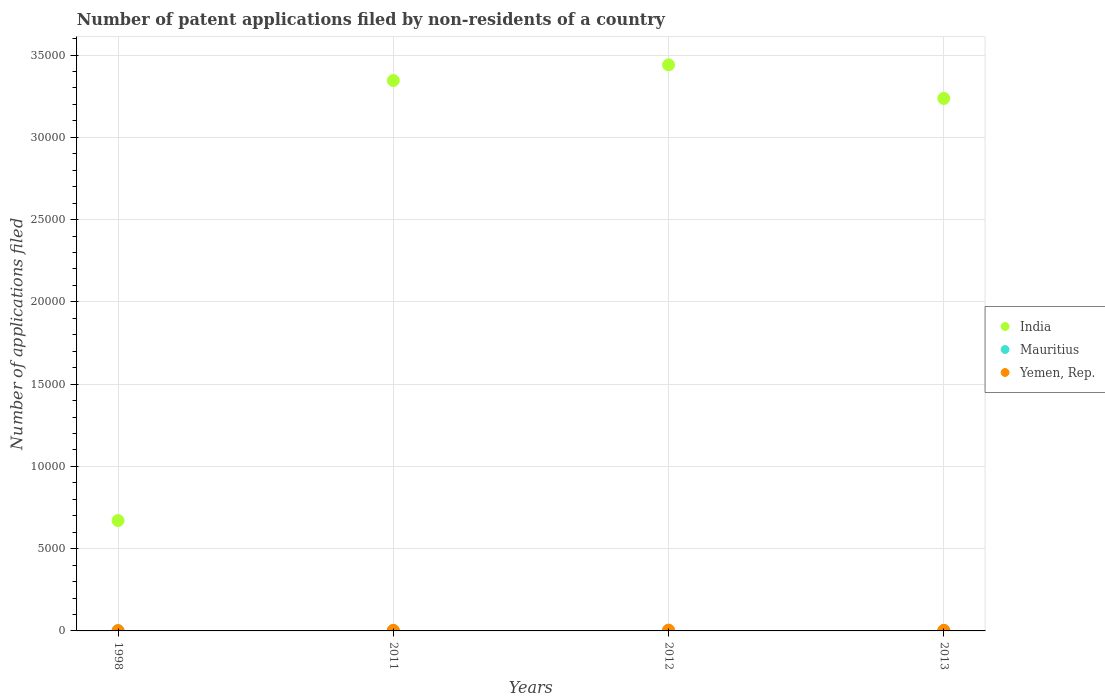How many different coloured dotlines are there?
Keep it short and to the point. 3. Is the number of dotlines equal to the number of legend labels?
Offer a terse response. Yes. Across all years, what is the maximum number of applications filed in India?
Your answer should be very brief. 3.44e+04. Across all years, what is the minimum number of applications filed in Mauritius?
Ensure brevity in your answer.  12. In which year was the number of applications filed in India maximum?
Offer a very short reply. 2012. In which year was the number of applications filed in India minimum?
Your answer should be compact. 1998. What is the total number of applications filed in India in the graph?
Ensure brevity in your answer.  1.07e+05. What is the difference between the number of applications filed in India in 2011 and that in 2012?
Your answer should be compact. -952. What is the difference between the number of applications filed in India in 2013 and the number of applications filed in Mauritius in 2012?
Your answer should be very brief. 3.23e+04. What is the average number of applications filed in Mauritius per year?
Keep it short and to the point. 15.75. In the year 2012, what is the difference between the number of applications filed in Mauritius and number of applications filed in Yemen, Rep.?
Provide a succinct answer. -35. In how many years, is the number of applications filed in Yemen, Rep. greater than 1000?
Your answer should be compact. 0. What is the ratio of the number of applications filed in India in 2011 to that in 2013?
Offer a terse response. 1.03. Is the difference between the number of applications filed in Mauritius in 2011 and 2012 greater than the difference between the number of applications filed in Yemen, Rep. in 2011 and 2012?
Your response must be concise. Yes. What is the difference between the highest and the second highest number of applications filed in Mauritius?
Give a very brief answer. 1. What is the difference between the highest and the lowest number of applications filed in India?
Keep it short and to the point. 2.77e+04. In how many years, is the number of applications filed in India greater than the average number of applications filed in India taken over all years?
Ensure brevity in your answer.  3. Is the sum of the number of applications filed in India in 1998 and 2012 greater than the maximum number of applications filed in Yemen, Rep. across all years?
Give a very brief answer. Yes. Is the number of applications filed in Mauritius strictly greater than the number of applications filed in India over the years?
Your response must be concise. No. How many legend labels are there?
Offer a terse response. 3. How are the legend labels stacked?
Ensure brevity in your answer.  Vertical. What is the title of the graph?
Your answer should be very brief. Number of patent applications filed by non-residents of a country. Does "Solomon Islands" appear as one of the legend labels in the graph?
Give a very brief answer. No. What is the label or title of the X-axis?
Offer a very short reply. Years. What is the label or title of the Y-axis?
Your answer should be compact. Number of applications filed. What is the Number of applications filed of India in 1998?
Your response must be concise. 6707. What is the Number of applications filed of Yemen, Rep. in 1998?
Keep it short and to the point. 16. What is the Number of applications filed in India in 2011?
Your response must be concise. 3.34e+04. What is the Number of applications filed in Mauritius in 2011?
Offer a very short reply. 19. What is the Number of applications filed in India in 2012?
Provide a short and direct response. 3.44e+04. What is the Number of applications filed in India in 2013?
Offer a very short reply. 3.24e+04. What is the Number of applications filed in Mauritius in 2013?
Keep it short and to the point. 18. Across all years, what is the maximum Number of applications filed in India?
Your response must be concise. 3.44e+04. Across all years, what is the maximum Number of applications filed of Yemen, Rep.?
Your answer should be very brief. 49. Across all years, what is the minimum Number of applications filed in India?
Give a very brief answer. 6707. Across all years, what is the minimum Number of applications filed in Mauritius?
Ensure brevity in your answer.  12. Across all years, what is the minimum Number of applications filed in Yemen, Rep.?
Offer a terse response. 16. What is the total Number of applications filed of India in the graph?
Make the answer very short. 1.07e+05. What is the total Number of applications filed in Yemen, Rep. in the graph?
Make the answer very short. 139. What is the difference between the Number of applications filed in India in 1998 and that in 2011?
Offer a terse response. -2.67e+04. What is the difference between the Number of applications filed of Yemen, Rep. in 1998 and that in 2011?
Your answer should be very brief. -21. What is the difference between the Number of applications filed of India in 1998 and that in 2012?
Ensure brevity in your answer.  -2.77e+04. What is the difference between the Number of applications filed in Yemen, Rep. in 1998 and that in 2012?
Offer a terse response. -33. What is the difference between the Number of applications filed of India in 1998 and that in 2013?
Ensure brevity in your answer.  -2.57e+04. What is the difference between the Number of applications filed of Mauritius in 1998 and that in 2013?
Make the answer very short. -6. What is the difference between the Number of applications filed in India in 2011 and that in 2012?
Ensure brevity in your answer.  -952. What is the difference between the Number of applications filed in Mauritius in 2011 and that in 2012?
Give a very brief answer. 5. What is the difference between the Number of applications filed of Yemen, Rep. in 2011 and that in 2012?
Your response must be concise. -12. What is the difference between the Number of applications filed of India in 2011 and that in 2013?
Provide a short and direct response. 1088. What is the difference between the Number of applications filed of Mauritius in 2011 and that in 2013?
Keep it short and to the point. 1. What is the difference between the Number of applications filed in Yemen, Rep. in 2011 and that in 2013?
Your answer should be very brief. 0. What is the difference between the Number of applications filed of India in 2012 and that in 2013?
Keep it short and to the point. 2040. What is the difference between the Number of applications filed in Yemen, Rep. in 2012 and that in 2013?
Provide a succinct answer. 12. What is the difference between the Number of applications filed in India in 1998 and the Number of applications filed in Mauritius in 2011?
Offer a terse response. 6688. What is the difference between the Number of applications filed in India in 1998 and the Number of applications filed in Yemen, Rep. in 2011?
Offer a terse response. 6670. What is the difference between the Number of applications filed of India in 1998 and the Number of applications filed of Mauritius in 2012?
Your answer should be compact. 6693. What is the difference between the Number of applications filed of India in 1998 and the Number of applications filed of Yemen, Rep. in 2012?
Provide a short and direct response. 6658. What is the difference between the Number of applications filed in Mauritius in 1998 and the Number of applications filed in Yemen, Rep. in 2012?
Provide a succinct answer. -37. What is the difference between the Number of applications filed of India in 1998 and the Number of applications filed of Mauritius in 2013?
Your answer should be very brief. 6689. What is the difference between the Number of applications filed of India in 1998 and the Number of applications filed of Yemen, Rep. in 2013?
Provide a succinct answer. 6670. What is the difference between the Number of applications filed of India in 2011 and the Number of applications filed of Mauritius in 2012?
Provide a short and direct response. 3.34e+04. What is the difference between the Number of applications filed in India in 2011 and the Number of applications filed in Yemen, Rep. in 2012?
Your answer should be compact. 3.34e+04. What is the difference between the Number of applications filed in India in 2011 and the Number of applications filed in Mauritius in 2013?
Ensure brevity in your answer.  3.34e+04. What is the difference between the Number of applications filed in India in 2011 and the Number of applications filed in Yemen, Rep. in 2013?
Keep it short and to the point. 3.34e+04. What is the difference between the Number of applications filed of India in 2012 and the Number of applications filed of Mauritius in 2013?
Keep it short and to the point. 3.44e+04. What is the difference between the Number of applications filed in India in 2012 and the Number of applications filed in Yemen, Rep. in 2013?
Give a very brief answer. 3.44e+04. What is the difference between the Number of applications filed of Mauritius in 2012 and the Number of applications filed of Yemen, Rep. in 2013?
Provide a short and direct response. -23. What is the average Number of applications filed of India per year?
Make the answer very short. 2.67e+04. What is the average Number of applications filed of Mauritius per year?
Ensure brevity in your answer.  15.75. What is the average Number of applications filed of Yemen, Rep. per year?
Keep it short and to the point. 34.75. In the year 1998, what is the difference between the Number of applications filed in India and Number of applications filed in Mauritius?
Ensure brevity in your answer.  6695. In the year 1998, what is the difference between the Number of applications filed of India and Number of applications filed of Yemen, Rep.?
Keep it short and to the point. 6691. In the year 2011, what is the difference between the Number of applications filed of India and Number of applications filed of Mauritius?
Your response must be concise. 3.34e+04. In the year 2011, what is the difference between the Number of applications filed in India and Number of applications filed in Yemen, Rep.?
Provide a succinct answer. 3.34e+04. In the year 2011, what is the difference between the Number of applications filed in Mauritius and Number of applications filed in Yemen, Rep.?
Offer a terse response. -18. In the year 2012, what is the difference between the Number of applications filed of India and Number of applications filed of Mauritius?
Keep it short and to the point. 3.44e+04. In the year 2012, what is the difference between the Number of applications filed of India and Number of applications filed of Yemen, Rep.?
Your response must be concise. 3.44e+04. In the year 2012, what is the difference between the Number of applications filed of Mauritius and Number of applications filed of Yemen, Rep.?
Ensure brevity in your answer.  -35. In the year 2013, what is the difference between the Number of applications filed in India and Number of applications filed in Mauritius?
Your response must be concise. 3.23e+04. In the year 2013, what is the difference between the Number of applications filed in India and Number of applications filed in Yemen, Rep.?
Offer a very short reply. 3.23e+04. What is the ratio of the Number of applications filed in India in 1998 to that in 2011?
Your response must be concise. 0.2. What is the ratio of the Number of applications filed of Mauritius in 1998 to that in 2011?
Provide a succinct answer. 0.63. What is the ratio of the Number of applications filed of Yemen, Rep. in 1998 to that in 2011?
Your answer should be compact. 0.43. What is the ratio of the Number of applications filed in India in 1998 to that in 2012?
Provide a succinct answer. 0.2. What is the ratio of the Number of applications filed in Yemen, Rep. in 1998 to that in 2012?
Give a very brief answer. 0.33. What is the ratio of the Number of applications filed of India in 1998 to that in 2013?
Ensure brevity in your answer.  0.21. What is the ratio of the Number of applications filed in Yemen, Rep. in 1998 to that in 2013?
Your answer should be compact. 0.43. What is the ratio of the Number of applications filed in India in 2011 to that in 2012?
Ensure brevity in your answer.  0.97. What is the ratio of the Number of applications filed of Mauritius in 2011 to that in 2012?
Keep it short and to the point. 1.36. What is the ratio of the Number of applications filed of Yemen, Rep. in 2011 to that in 2012?
Make the answer very short. 0.76. What is the ratio of the Number of applications filed in India in 2011 to that in 2013?
Your answer should be very brief. 1.03. What is the ratio of the Number of applications filed in Mauritius in 2011 to that in 2013?
Offer a terse response. 1.06. What is the ratio of the Number of applications filed in India in 2012 to that in 2013?
Keep it short and to the point. 1.06. What is the ratio of the Number of applications filed in Yemen, Rep. in 2012 to that in 2013?
Keep it short and to the point. 1.32. What is the difference between the highest and the second highest Number of applications filed in India?
Your answer should be very brief. 952. What is the difference between the highest and the second highest Number of applications filed in Yemen, Rep.?
Keep it short and to the point. 12. What is the difference between the highest and the lowest Number of applications filed in India?
Provide a succinct answer. 2.77e+04. What is the difference between the highest and the lowest Number of applications filed in Mauritius?
Your answer should be very brief. 7. What is the difference between the highest and the lowest Number of applications filed of Yemen, Rep.?
Ensure brevity in your answer.  33. 